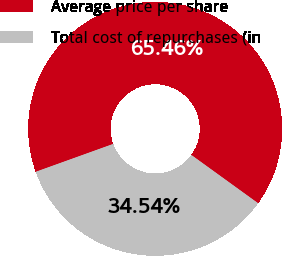<chart> <loc_0><loc_0><loc_500><loc_500><pie_chart><fcel>Average price per share<fcel>Total cost of repurchases (in<nl><fcel>65.46%<fcel>34.54%<nl></chart> 